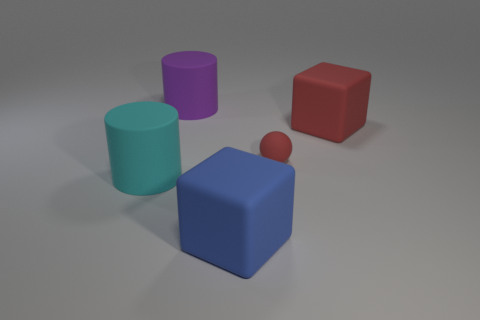Add 1 purple cylinders. How many objects exist? 6 Subtract all cylinders. How many objects are left? 3 Subtract all purple cylinders. Subtract all red rubber cubes. How many objects are left? 3 Add 5 blue rubber cubes. How many blue rubber cubes are left? 6 Add 1 cyan matte objects. How many cyan matte objects exist? 2 Subtract 0 purple spheres. How many objects are left? 5 